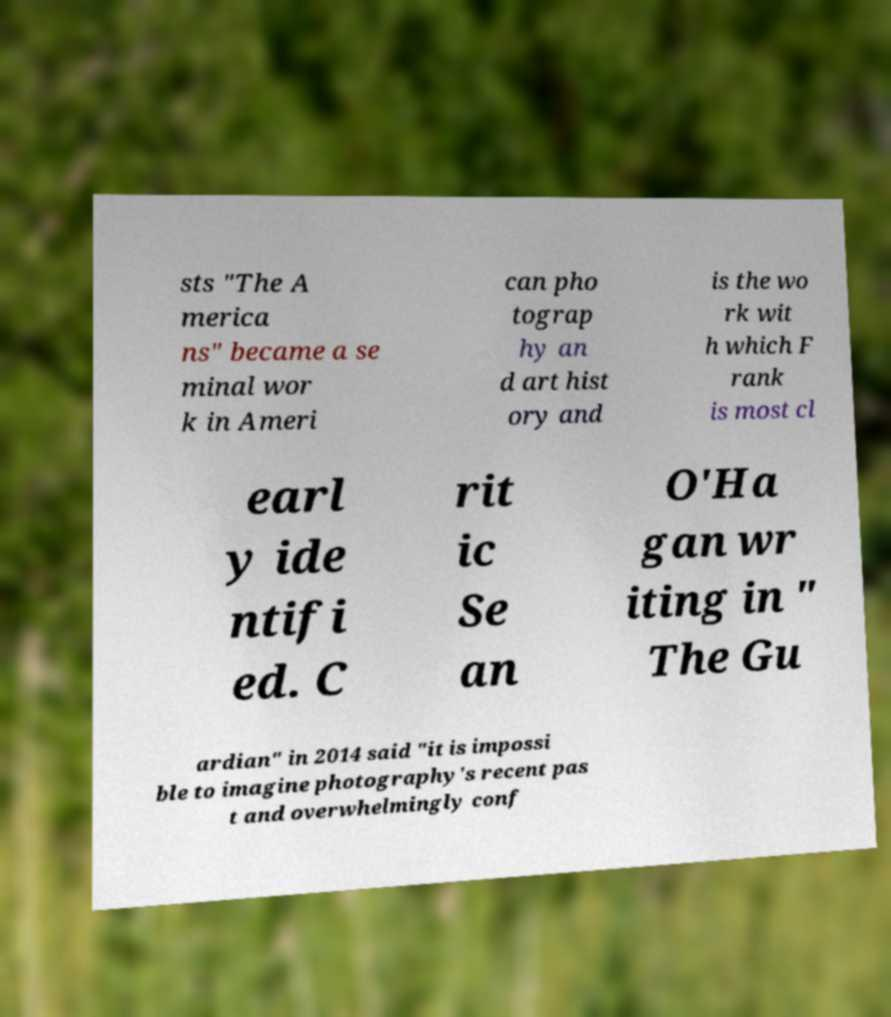There's text embedded in this image that I need extracted. Can you transcribe it verbatim? sts "The A merica ns" became a se minal wor k in Ameri can pho tograp hy an d art hist ory and is the wo rk wit h which F rank is most cl earl y ide ntifi ed. C rit ic Se an O'Ha gan wr iting in " The Gu ardian" in 2014 said "it is impossi ble to imagine photography's recent pas t and overwhelmingly conf 